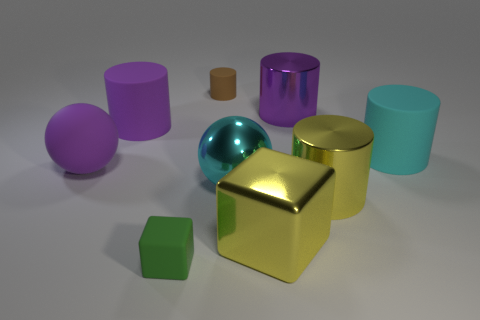How many purple cylinders must be subtracted to get 1 purple cylinders? 1 Subtract all metallic cylinders. How many cylinders are left? 3 Subtract all spheres. How many objects are left? 7 Subtract 2 cylinders. How many cylinders are left? 3 Subtract all yellow blocks. Subtract all blue balls. How many blocks are left? 1 Subtract all cyan cubes. How many green cylinders are left? 0 Subtract all purple objects. Subtract all big purple cylinders. How many objects are left? 4 Add 5 big purple cylinders. How many big purple cylinders are left? 7 Add 2 yellow blocks. How many yellow blocks exist? 3 Add 1 metallic objects. How many objects exist? 10 